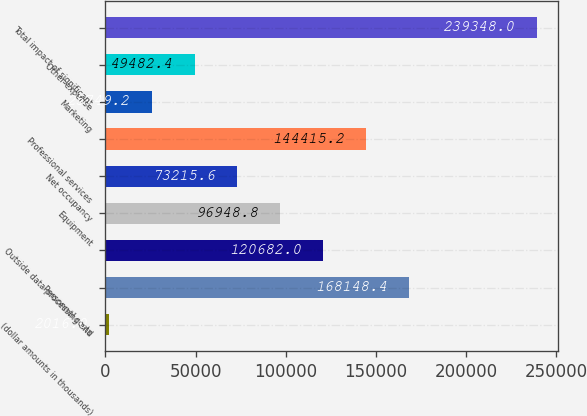Convert chart. <chart><loc_0><loc_0><loc_500><loc_500><bar_chart><fcel>(dollar amounts in thousands)<fcel>Personnel costs<fcel>Outside data processing and<fcel>Equipment<fcel>Net occupancy<fcel>Professional services<fcel>Marketing<fcel>Other expense<fcel>Total impact of significant<nl><fcel>2016<fcel>168148<fcel>120682<fcel>96948.8<fcel>73215.6<fcel>144415<fcel>25749.2<fcel>49482.4<fcel>239348<nl></chart> 